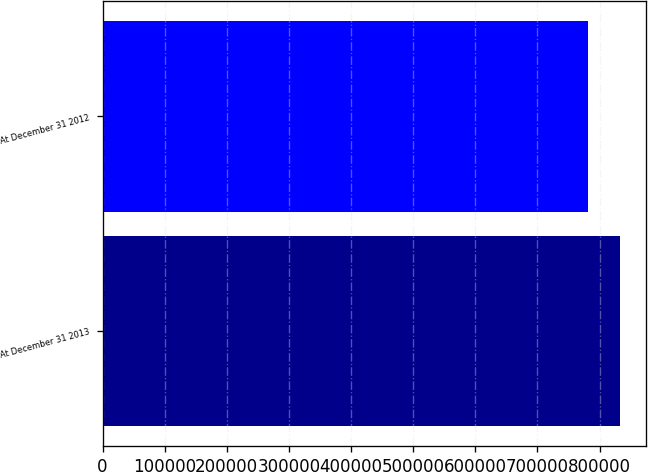Convert chart to OTSL. <chart><loc_0><loc_0><loc_500><loc_500><bar_chart><fcel>At December 31 2013<fcel>At December 31 2012<nl><fcel>832702<fcel>780960<nl></chart> 